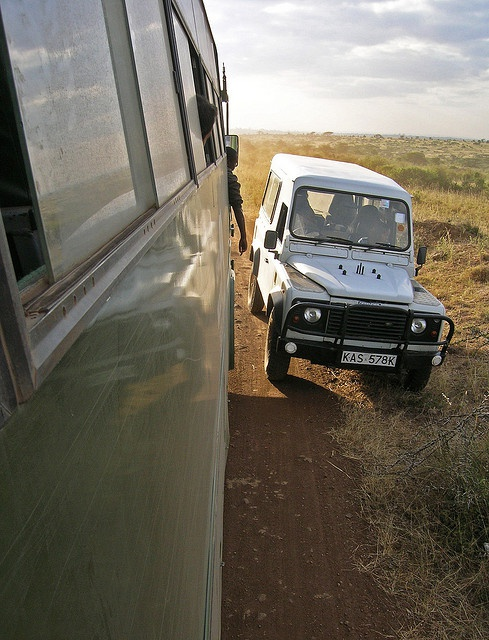Describe the objects in this image and their specific colors. I can see bus in gray, black, darkgray, and darkgreen tones, truck in gray, black, darkgray, and white tones, car in gray, black, darkgray, and white tones, and people in gray, black, and tan tones in this image. 